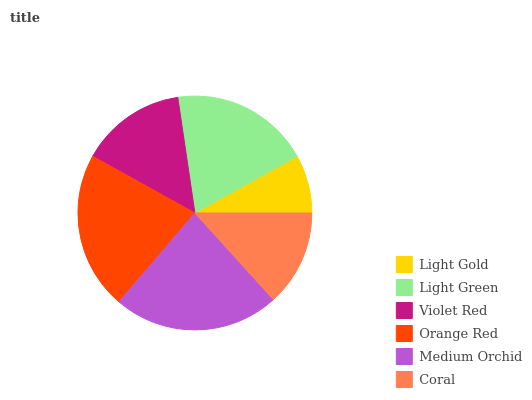Is Light Gold the minimum?
Answer yes or no. Yes. Is Medium Orchid the maximum?
Answer yes or no. Yes. Is Light Green the minimum?
Answer yes or no. No. Is Light Green the maximum?
Answer yes or no. No. Is Light Green greater than Light Gold?
Answer yes or no. Yes. Is Light Gold less than Light Green?
Answer yes or no. Yes. Is Light Gold greater than Light Green?
Answer yes or no. No. Is Light Green less than Light Gold?
Answer yes or no. No. Is Light Green the high median?
Answer yes or no. Yes. Is Violet Red the low median?
Answer yes or no. Yes. Is Orange Red the high median?
Answer yes or no. No. Is Light Green the low median?
Answer yes or no. No. 